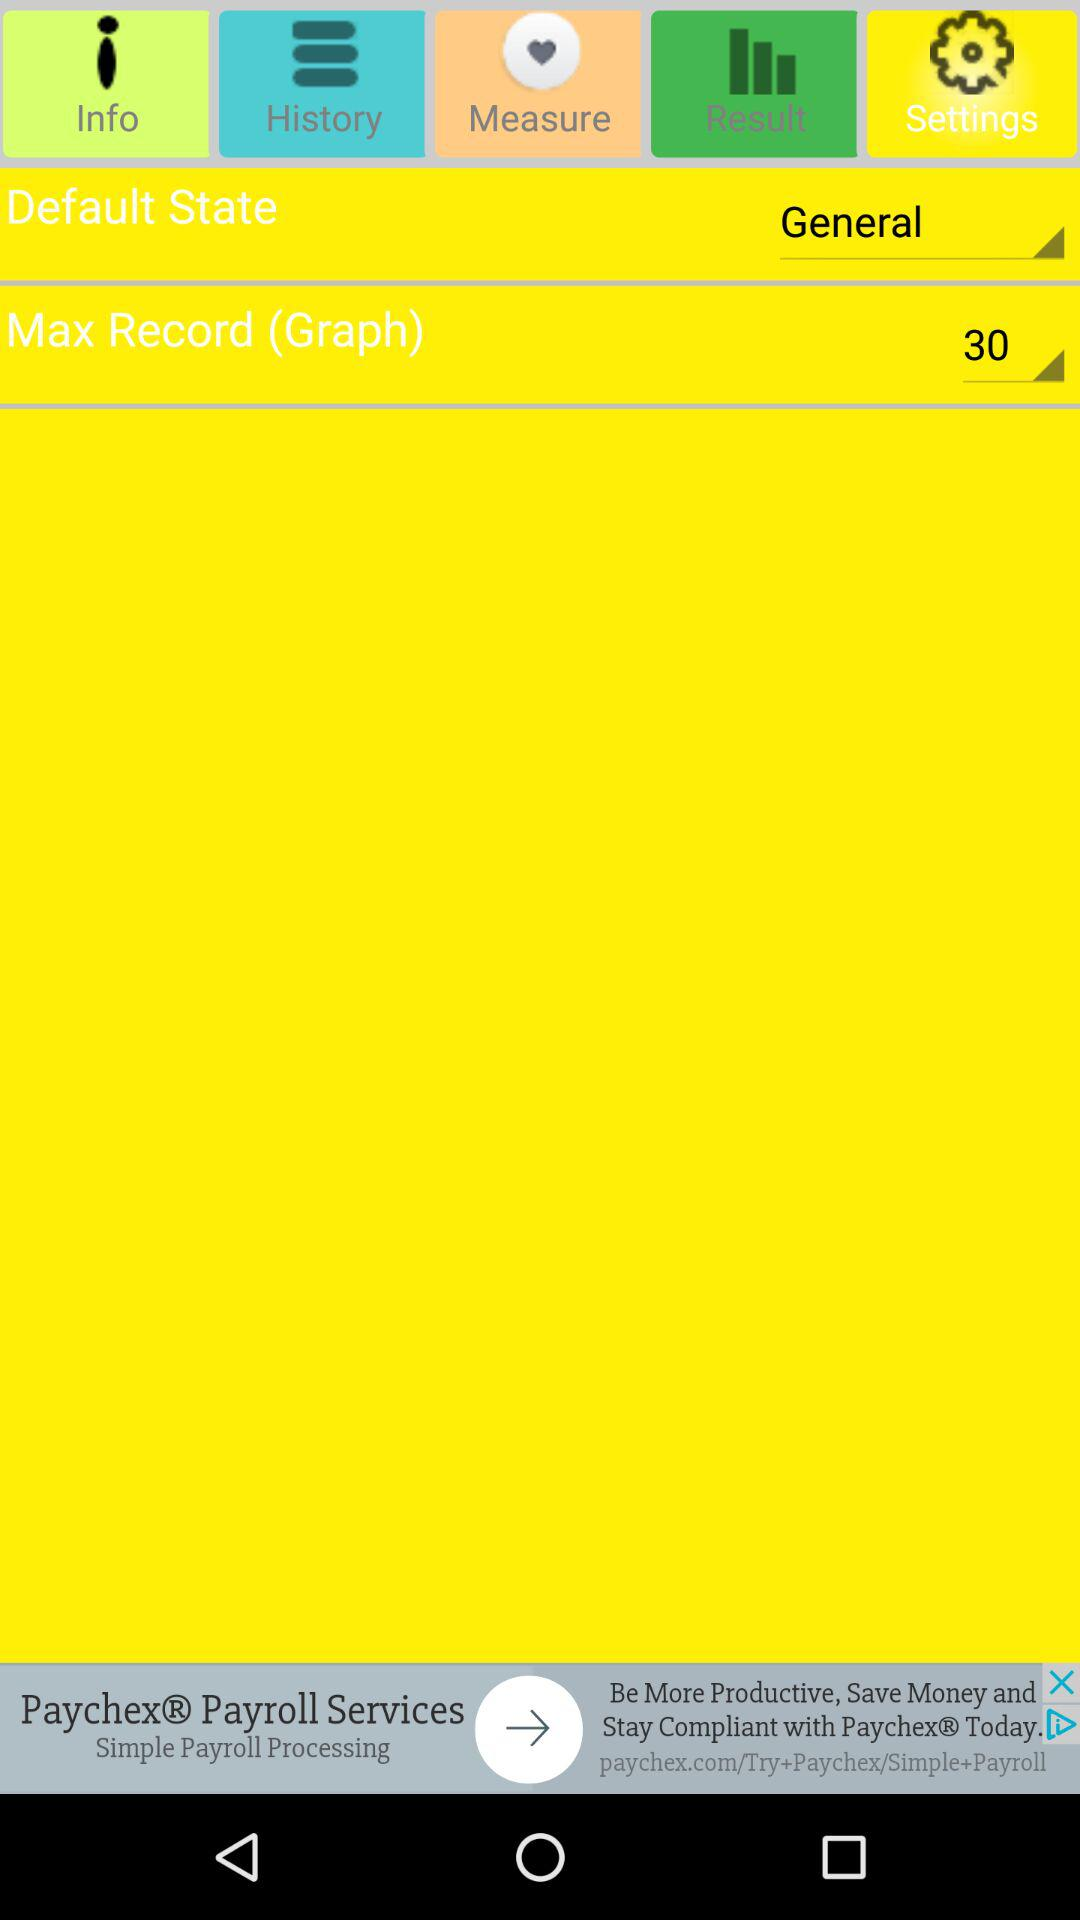What is the default state? The default state is "General". 